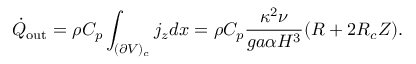Convert formula to latex. <formula><loc_0><loc_0><loc_500><loc_500>\dot { Q } _ { o u t } = \rho C _ { p } \int _ { ( \partial V ) _ { c } } j _ { z } d x = \rho C _ { p } \frac { \kappa ^ { 2 } \nu } { g a \alpha H ^ { 3 } } ( R + 2 R _ { c } Z ) .</formula> 